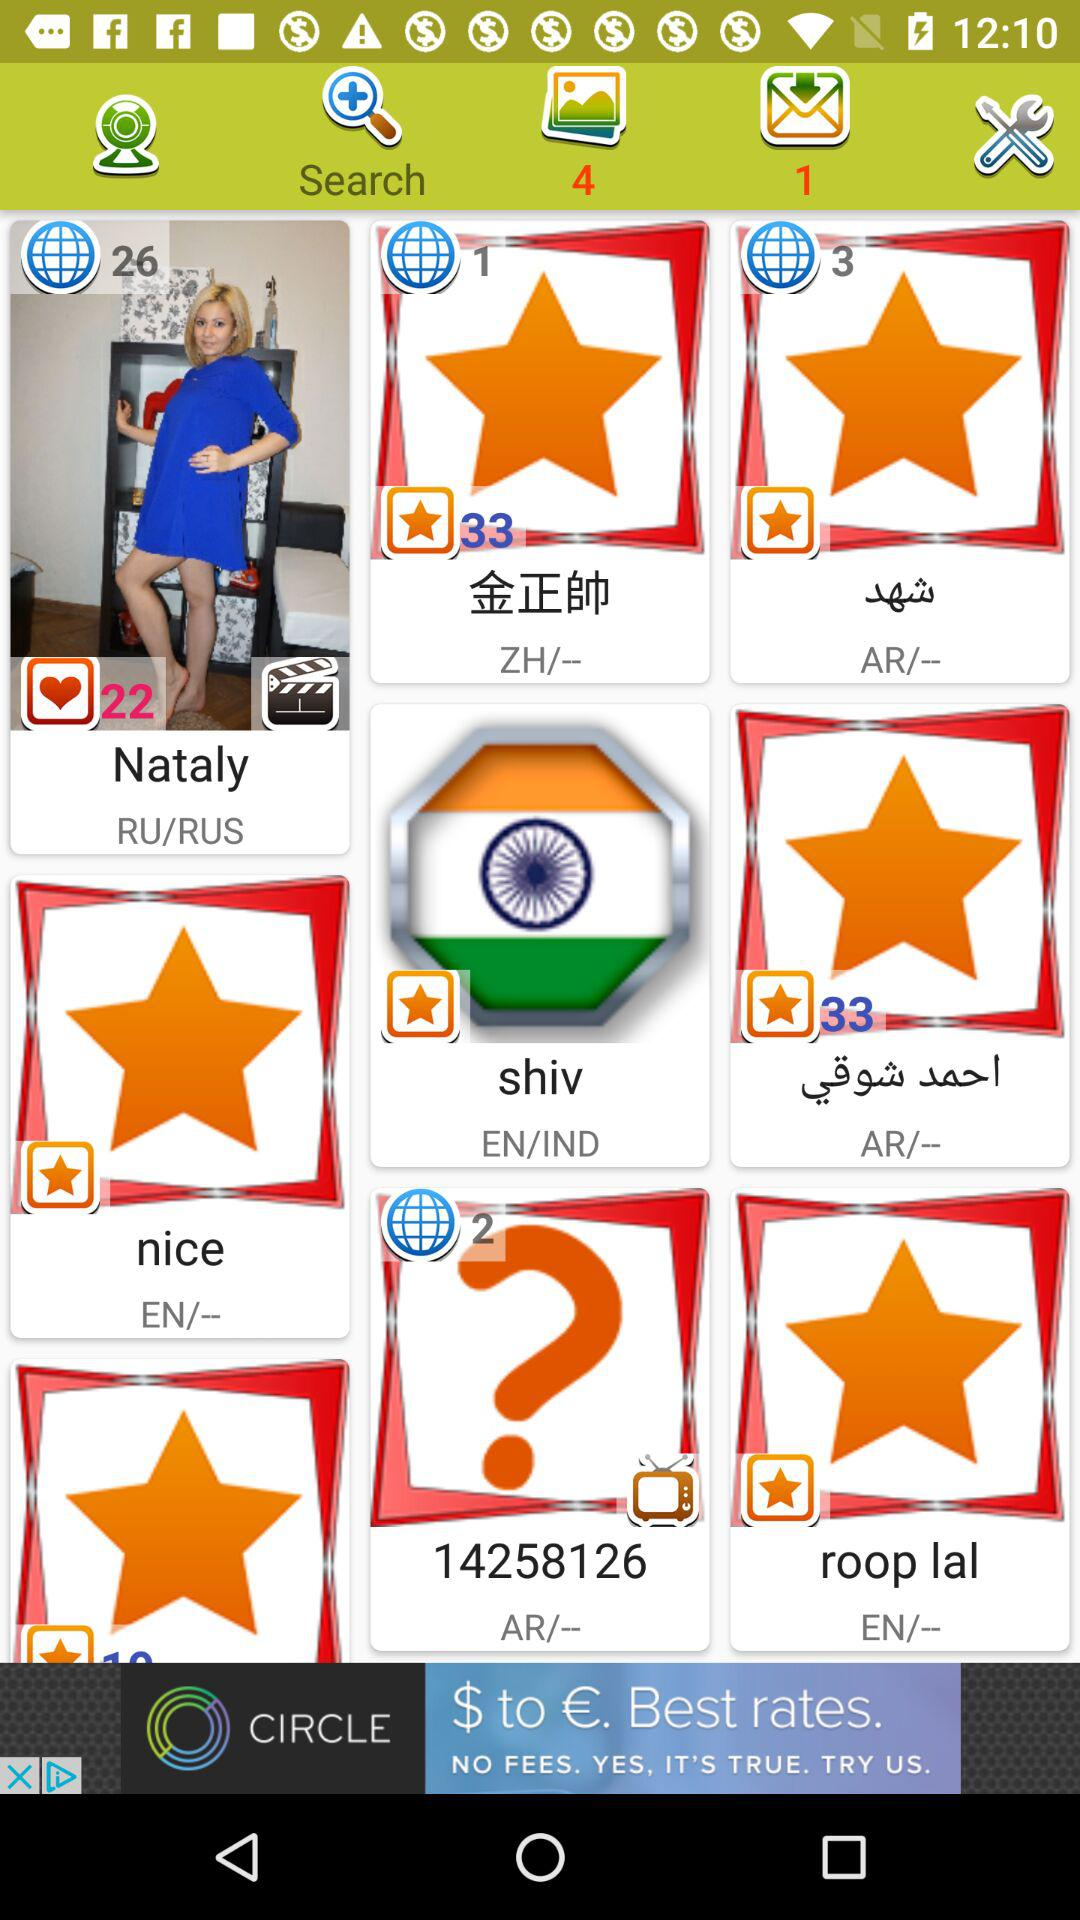How many stars are shown in roop lal?
When the provided information is insufficient, respond with <no answer>. <no answer> 